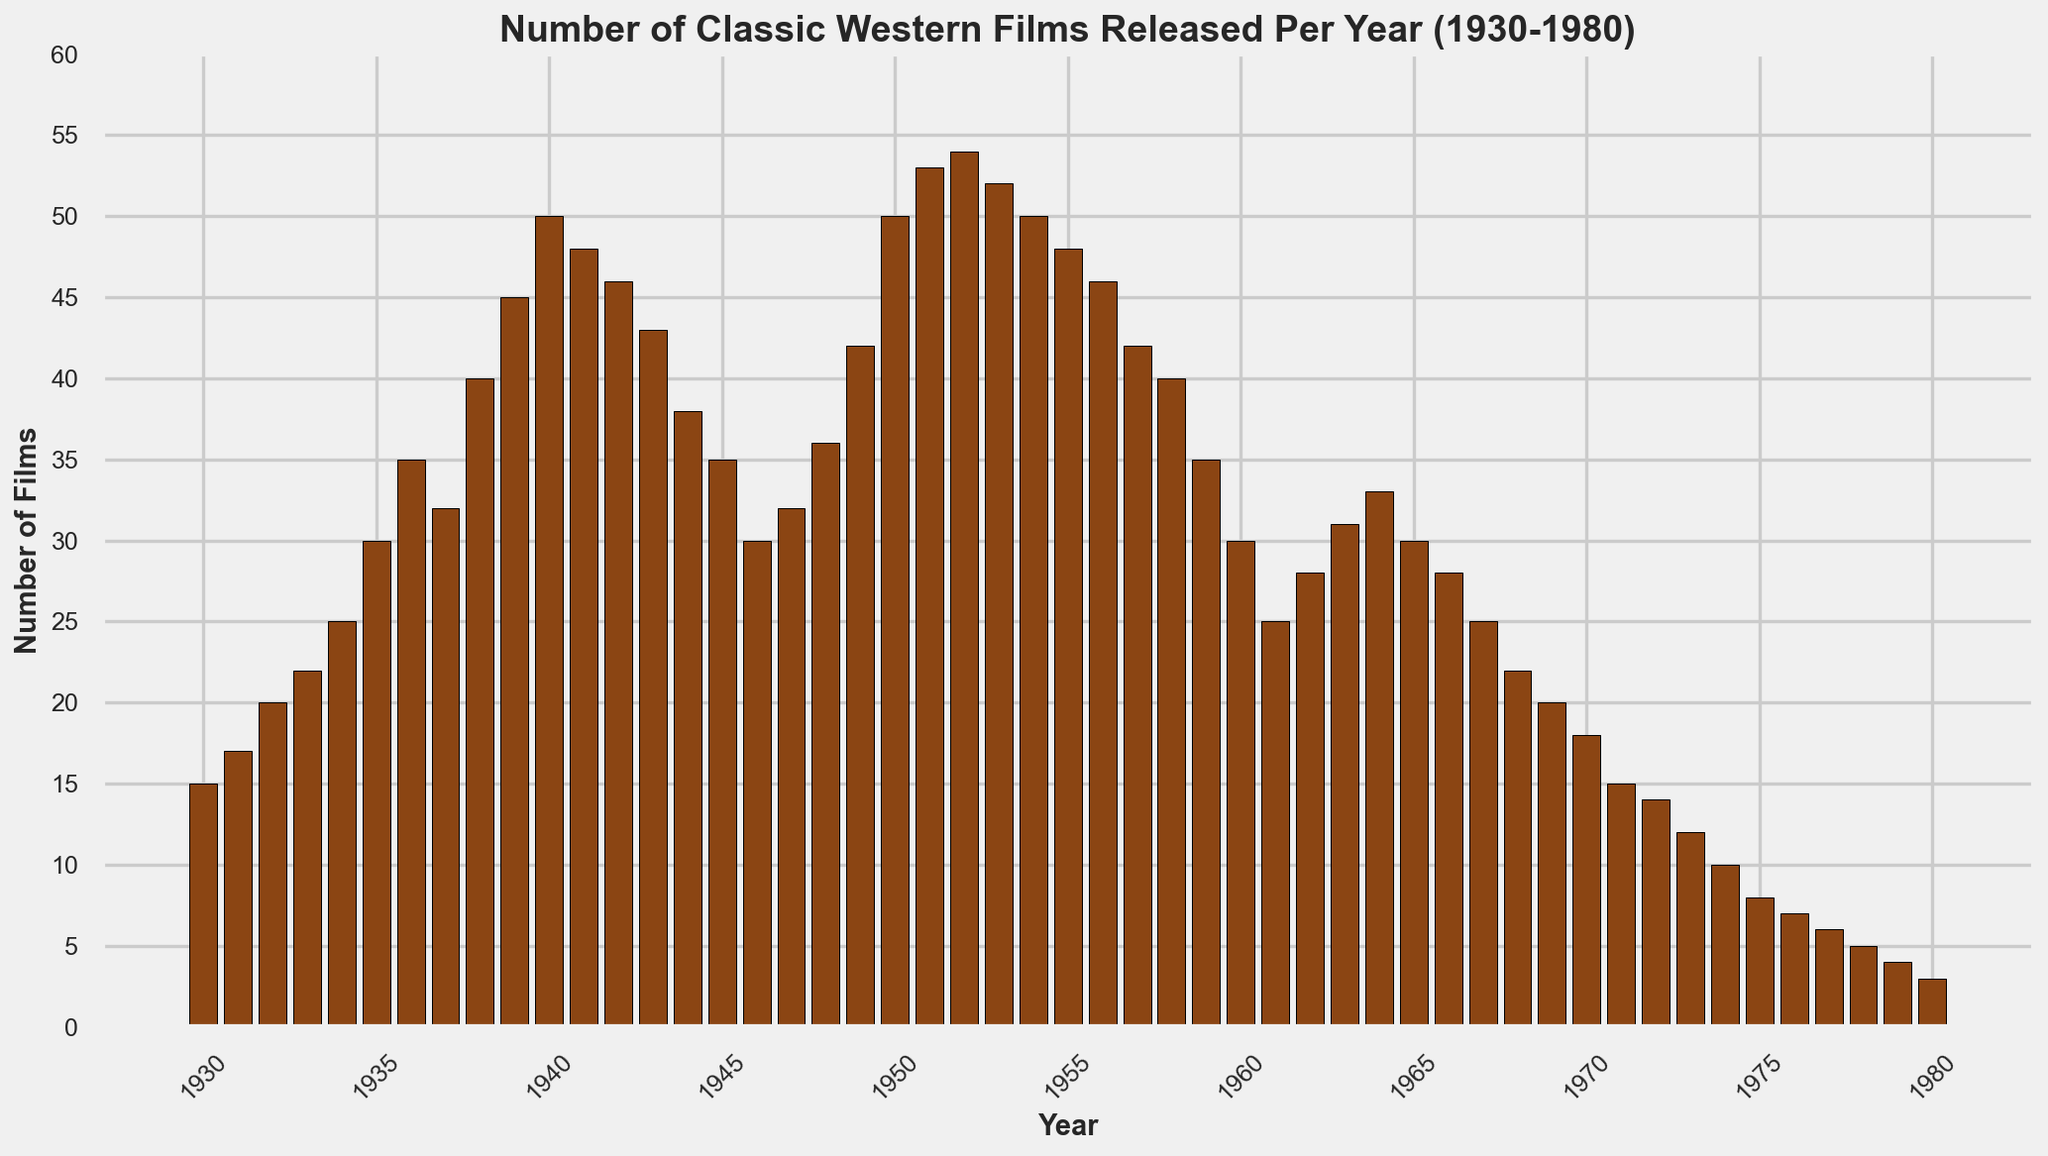Which year saw the highest number of classic Western films released? The highest number of films is indicated by the tallest bar. Observing the chart, it is in the years 1951 and 1952 with 54 films.
Answer: 1951 and 1952 By how much did the number of films released in 1940 exceed those released in 1935? Locate the bars for 1940 and 1935 and then find the difference. 1940 had 50 films and 1935 had 30 films. The difference is 50 - 30 = 20.
Answer: 20 What is the average number of films released per year in the 1940s? Sum the number of films from 1940 to 1949 and divide by the number of years. (50 + 48 + 46 + 43 + 38 + 35 + 32 + 36 + 42 + 50) / 10 = 420 / 10 = 42.
Answer: 42 Between which consecutive years did the number of released films increase the most between 1930 and 1980? Compare the differences in the height of bars between consecutive years and identify the maximum increase. The largest increase is between 1938 (40 films) and 1939 (45 films), which is 45 - 40 = 5.
Answer: 1938 and 1939 How many years had more than 40 films released? Count the bars that represent more than 40 films. These are the years 1939 (45), 1940 (50), 1941 (48), 1942 (46), 1943 (43), 1949 (42), 1950 (50), 1951 (53), 1952 (54), 1953 (52), 1954 (50), 1955 (48). There are 12 years in total.
Answer: 12 years Which decade had the highest average number of films released per year? Calculate the average number of films per year for each decade and compare them. 1940s: 42, 1950s: 47.5, 1960s: 29.2, 1970s: 10.8. The 1950s had the highest average.
Answer: 1950s What is the median number of films released per year from 1930 to 1980? List all the numbers of films, sort them, and find the middle value. The numbers are 15, 17, 20, 22, 25, 30, 35, 32, 40, 45, 50, 48, 46, 43, 38, 35, 30, 32, 36, 42, 50, 53, 54, 52, 50, 48, 46, 42, 40, 35, 30, 25, 28, 31, 33, 30, 28, 25, 22, 20, 18, 15, 14, 12, 10, 8, 7, 6, 5, 4, 3. The median is the average of the 25th and 26th values (36 and 35), (36 + 35)/2 = 35.5.
Answer: 35.5 How many years had the number of released films increase compared to the previous year? Count the instances where the bar height of a given year is greater than that of the preceding year. The years 1931, 1932, 1933, 1934, 1935, 1936, 1938, 1939, and several others fit this condition. After counting, the total is 28.
Answer: 28 years 